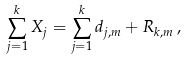Convert formula to latex. <formula><loc_0><loc_0><loc_500><loc_500>\sum _ { j = 1 } ^ { k } X _ { j } = \sum _ { j = 1 } ^ { k } d _ { j , m } + R _ { k , m } \, ,</formula> 